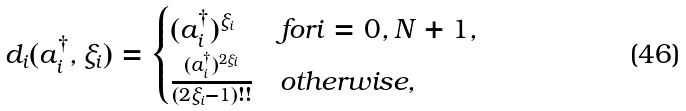Convert formula to latex. <formula><loc_0><loc_0><loc_500><loc_500>d _ { i } ( a _ { i } ^ { \dagger } , \xi _ { i } ) = \begin{cases} ( a _ { i } ^ { \dagger } ) ^ { \xi _ { i } } & f o r i = 0 , N + 1 , \\ \frac { ( a _ { i } ^ { \dagger } ) ^ { 2 \xi _ { i } } } { ( 2 \xi _ { i } - 1 ) ! ! } & o t h e r w i s e , \end{cases}</formula> 